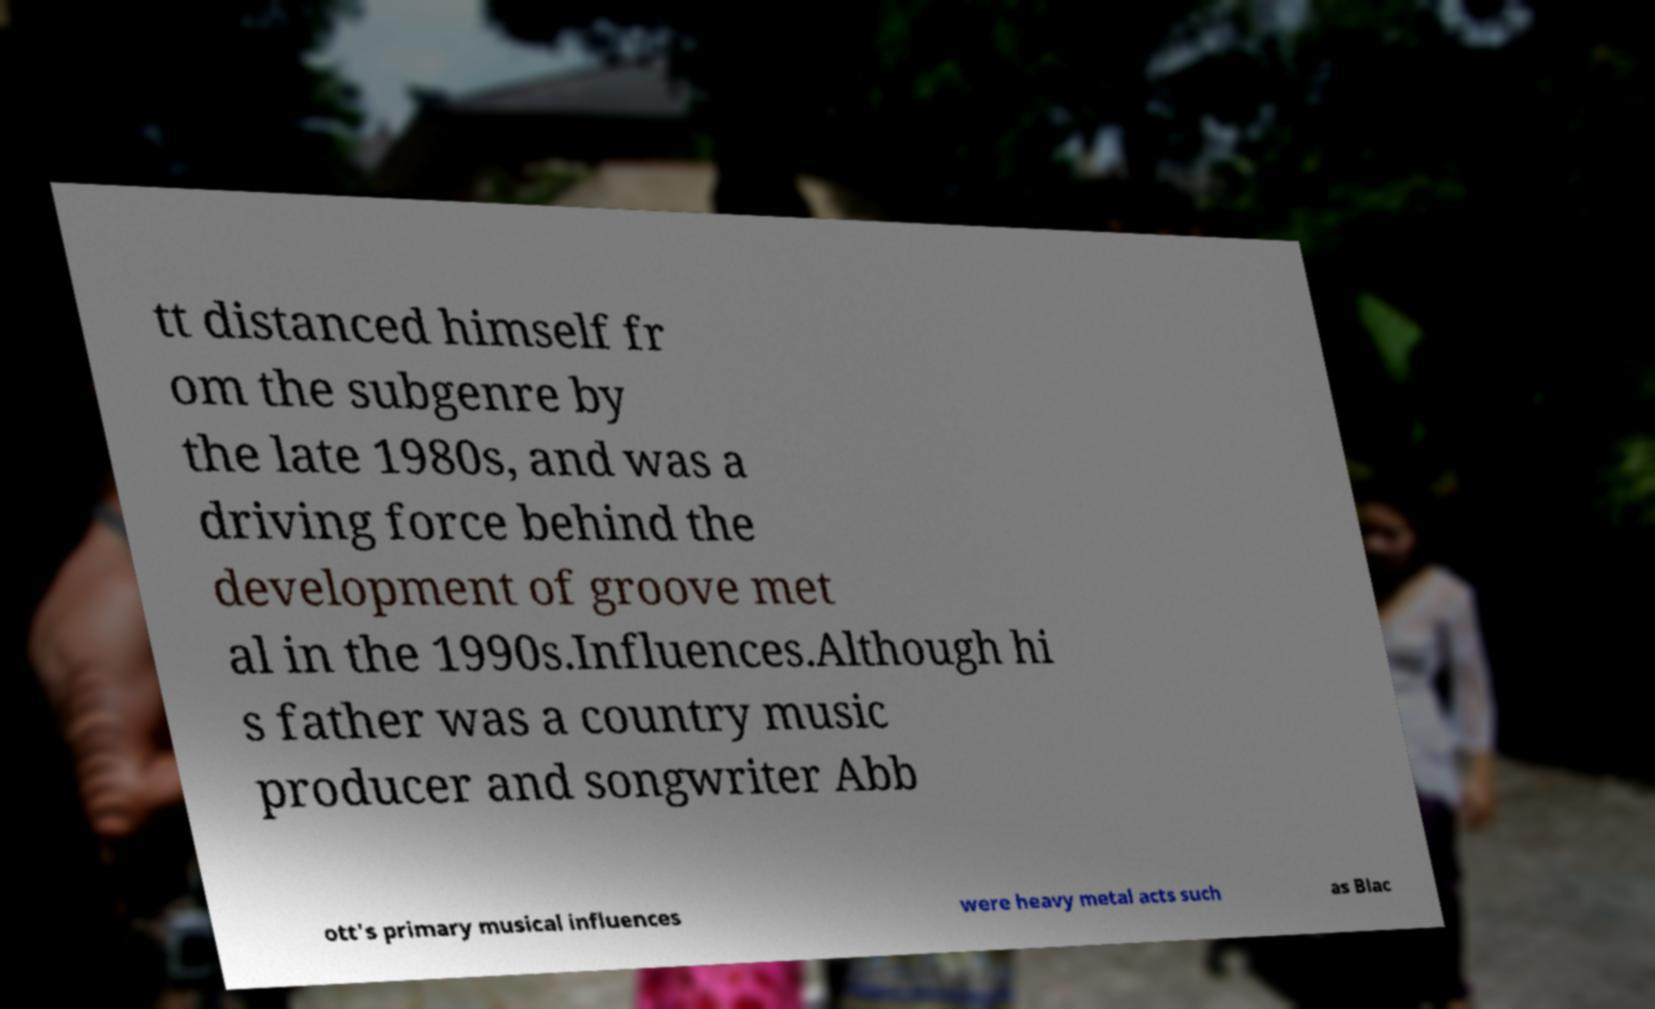I need the written content from this picture converted into text. Can you do that? tt distanced himself fr om the subgenre by the late 1980s, and was a driving force behind the development of groove met al in the 1990s.Influences.Although hi s father was a country music producer and songwriter Abb ott's primary musical influences were heavy metal acts such as Blac 